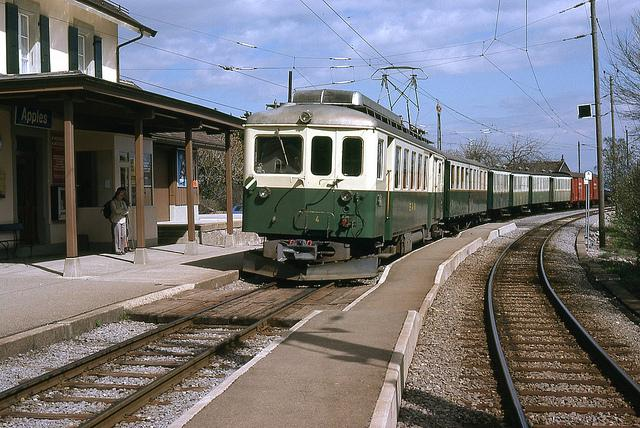What does this train primarily carry? Please explain your reasoning. passengers. It has windows along both sides and is stopping for the person waiting on the platform. 